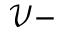Convert formula to latex. <formula><loc_0><loc_0><loc_500><loc_500>\mathcal { V } -</formula> 